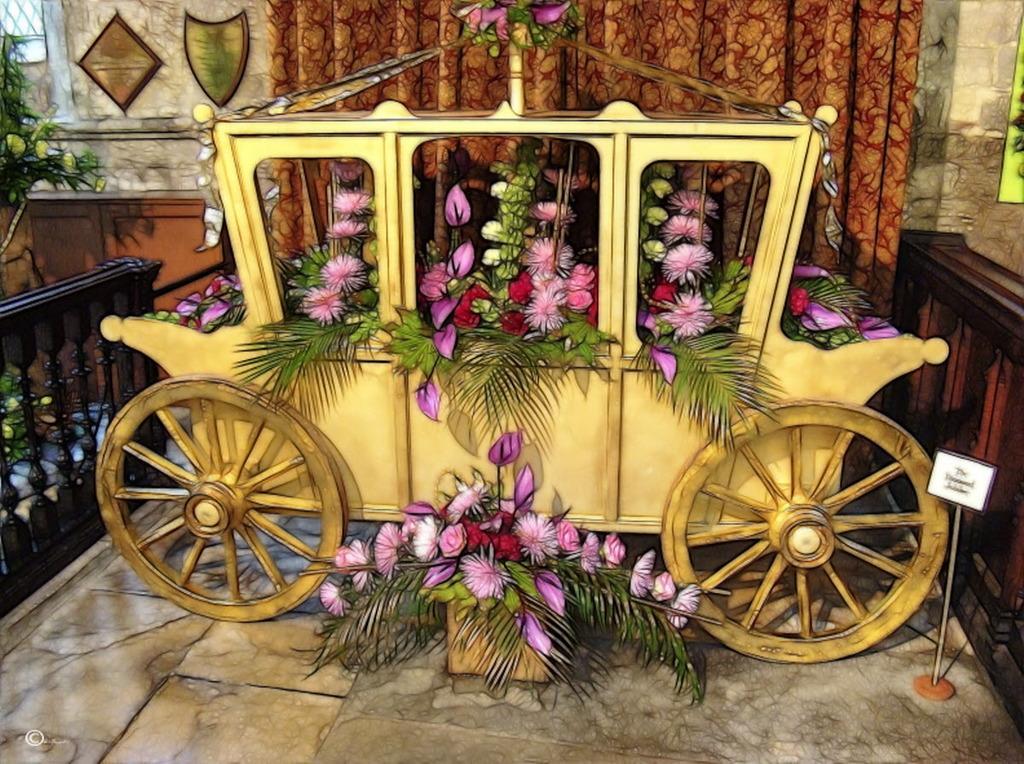How would you summarize this image in a sentence or two? In this image, there is an art contains a vehicle beside the curtain filled with some flowers. There is a flowers pot at the bottom of the image. 